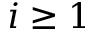Convert formula to latex. <formula><loc_0><loc_0><loc_500><loc_500>i \geq 1</formula> 